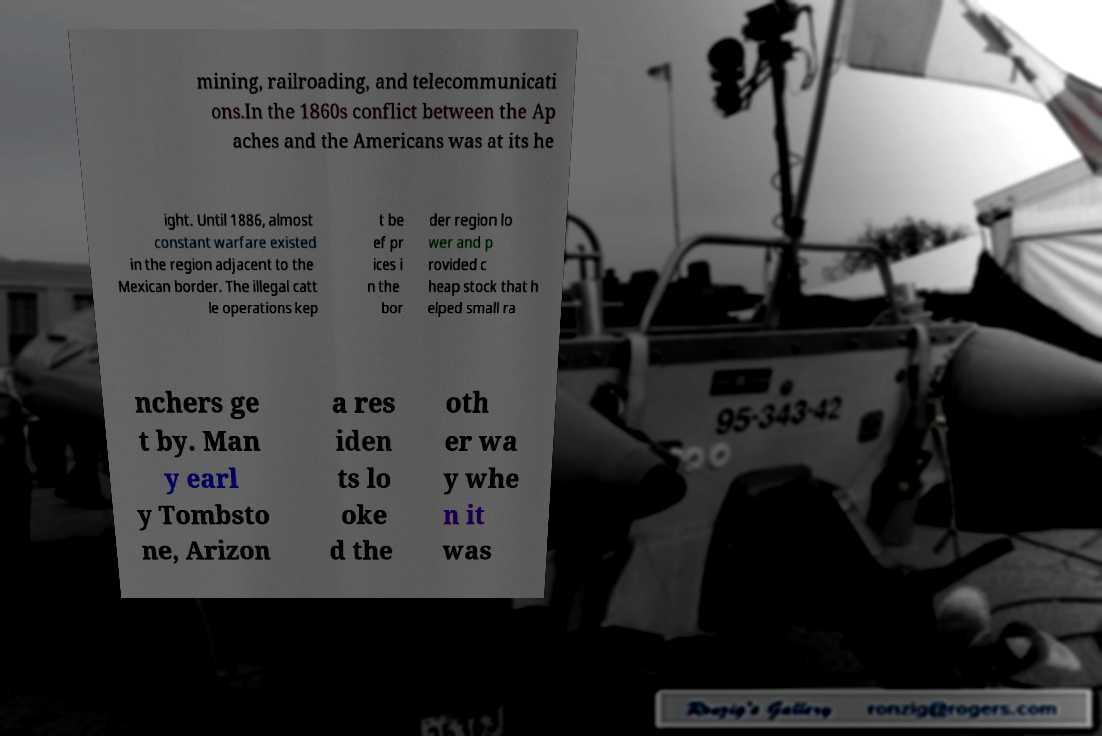Can you read and provide the text displayed in the image?This photo seems to have some interesting text. Can you extract and type it out for me? mining, railroading, and telecommunicati ons.In the 1860s conflict between the Ap aches and the Americans was at its he ight. Until 1886, almost constant warfare existed in the region adjacent to the Mexican border. The illegal catt le operations kep t be ef pr ices i n the bor der region lo wer and p rovided c heap stock that h elped small ra nchers ge t by. Man y earl y Tombsto ne, Arizon a res iden ts lo oke d the oth er wa y whe n it was 